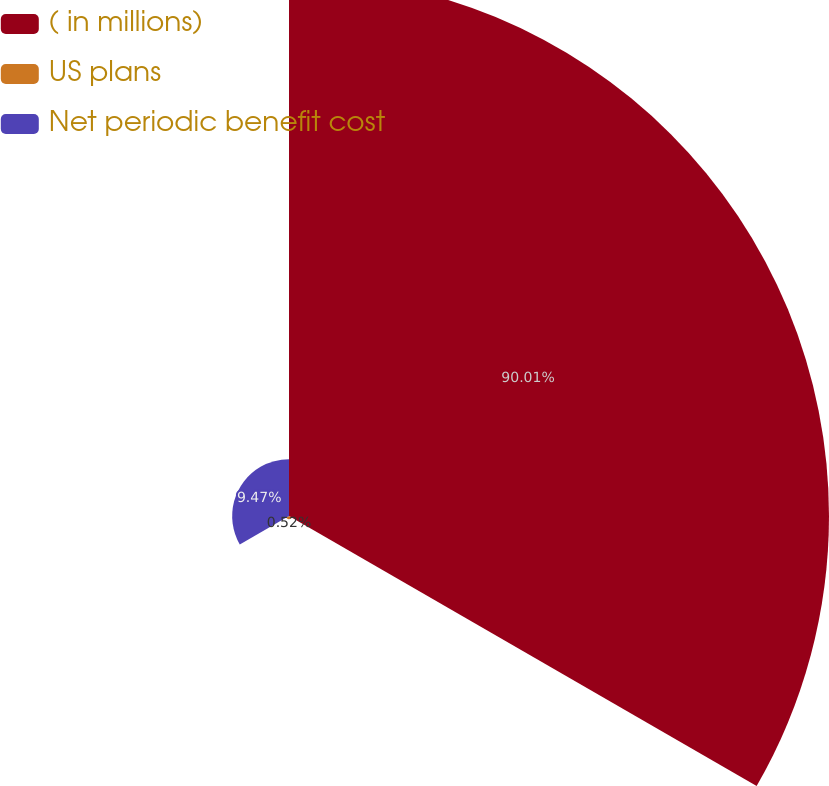Convert chart to OTSL. <chart><loc_0><loc_0><loc_500><loc_500><pie_chart><fcel>( in millions)<fcel>US plans<fcel>Net periodic benefit cost<nl><fcel>90.0%<fcel>0.52%<fcel>9.47%<nl></chart> 